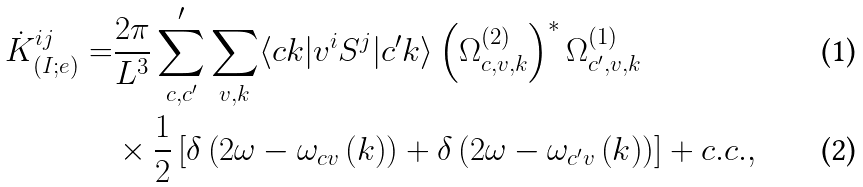<formula> <loc_0><loc_0><loc_500><loc_500>\dot { K } _ { ( I ; e ) } ^ { i j } = & \frac { 2 \pi } { L ^ { 3 } } \sum _ { c , c ^ { \prime } } ^ { \prime } \sum _ { v , k } \langle c k | v ^ { i } S ^ { j } | c ^ { \prime } k \rangle \left ( \Omega _ { c , v , k } ^ { \left ( 2 \right ) } \right ) ^ { * } \Omega _ { c ^ { \prime } , v , k } ^ { \left ( 1 \right ) } \\ & \times \frac { 1 } { 2 } \left [ \delta \left ( 2 \omega - \omega _ { c v } \left ( k \right ) \right ) + \delta \left ( 2 \omega - \omega _ { c ^ { \prime } v } \left ( k \right ) \right ) \right ] + c . c . ,</formula> 